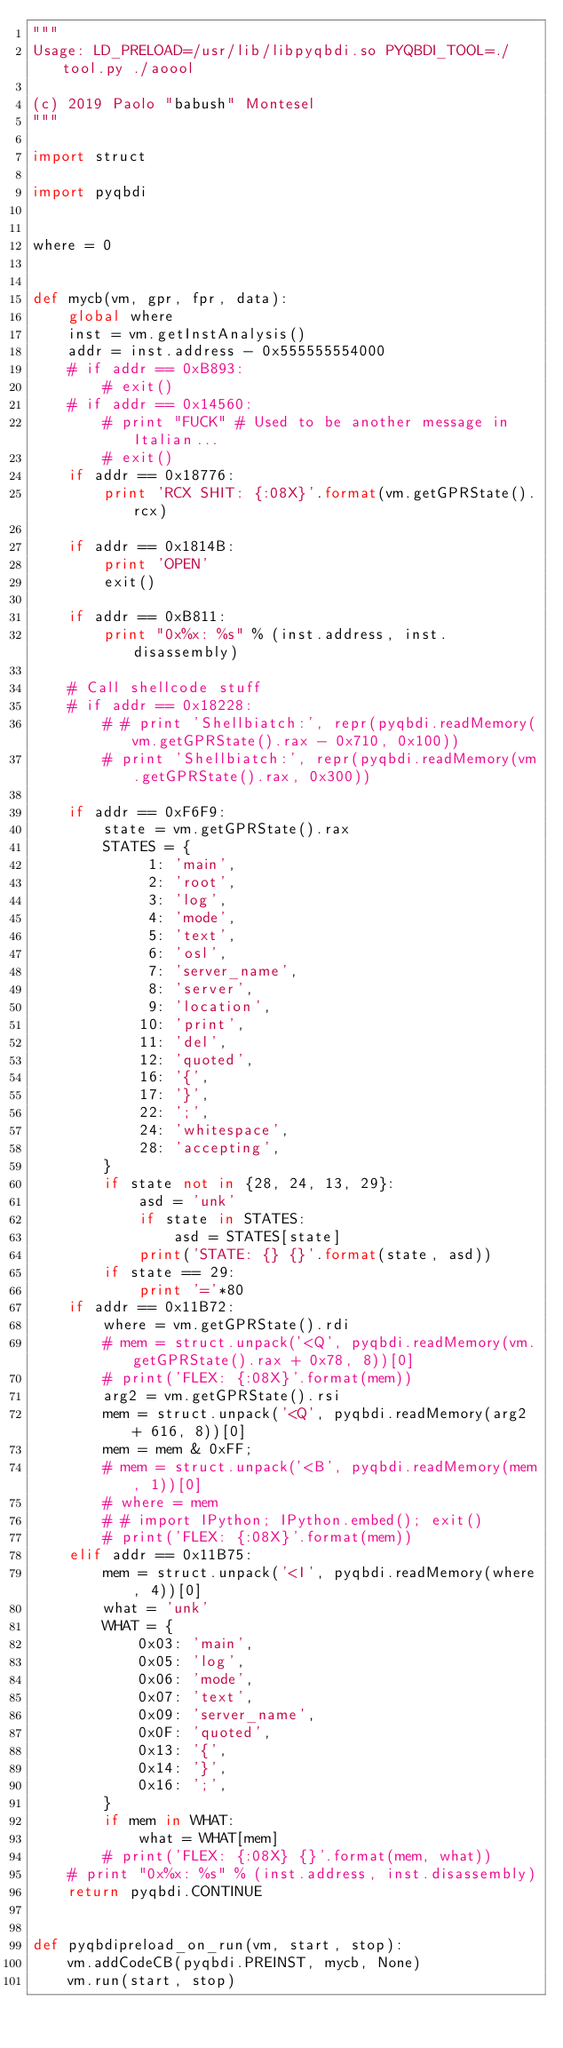Convert code to text. <code><loc_0><loc_0><loc_500><loc_500><_Python_>"""
Usage: LD_PRELOAD=/usr/lib/libpyqbdi.so PYQBDI_TOOL=./tool.py ./aoool

(c) 2019 Paolo "babush" Montesel
"""

import struct

import pyqbdi


where = 0


def mycb(vm, gpr, fpr, data):
    global where
    inst = vm.getInstAnalysis()
    addr = inst.address - 0x555555554000
    # if addr == 0xB893:
        # exit()
    # if addr == 0x14560:
        # print "FUCK" # Used to be another message in Italian...
        # exit()
    if addr == 0x18776:
        print 'RCX SHIT: {:08X}'.format(vm.getGPRState().rcx)

    if addr == 0x1814B:
        print 'OPEN'
        exit()

    if addr == 0xB811:
        print "0x%x: %s" % (inst.address, inst.disassembly)

    # Call shellcode stuff
    # if addr == 0x18228:
        # # print 'Shellbiatch:', repr(pyqbdi.readMemory(vm.getGPRState().rax - 0x710, 0x100))
        # print 'Shellbiatch:', repr(pyqbdi.readMemory(vm.getGPRState().rax, 0x300))

    if addr == 0xF6F9:
        state = vm.getGPRState().rax
        STATES = {
             1: 'main',
             2: 'root',
             3: 'log',
             4: 'mode',
             5: 'text',
             6: 'osl',
             7: 'server_name',
             8: 'server',
             9: 'location',
            10: 'print',
            11: 'del',
            12: 'quoted',
            16: '{',
            17: '}',
            22: ';',
            24: 'whitespace',
            28: 'accepting',
        }
        if state not in {28, 24, 13, 29}:
            asd = 'unk'
            if state in STATES:
                asd = STATES[state]
            print('STATE: {} {}'.format(state, asd))
        if state == 29:
            print '='*80
    if addr == 0x11B72:
        where = vm.getGPRState().rdi
        # mem = struct.unpack('<Q', pyqbdi.readMemory(vm.getGPRState().rax + 0x78, 8))[0]
        # print('FLEX: {:08X}'.format(mem))
        arg2 = vm.getGPRState().rsi
        mem = struct.unpack('<Q', pyqbdi.readMemory(arg2 + 616, 8))[0]
        mem = mem & 0xFF;
        # mem = struct.unpack('<B', pyqbdi.readMemory(mem, 1))[0]
        # where = mem
        # # import IPython; IPython.embed(); exit()
        # print('FLEX: {:08X}'.format(mem))
    elif addr == 0x11B75:
        mem = struct.unpack('<I', pyqbdi.readMemory(where, 4))[0]
        what = 'unk'
        WHAT = {
            0x03: 'main',
            0x05: 'log',
            0x06: 'mode',
            0x07: 'text',
            0x09: 'server_name',
            0x0F: 'quoted',
            0x13: '{',
            0x14: '}',
            0x16: ';',
        }
        if mem in WHAT:
            what = WHAT[mem]
        # print('FLEX: {:08X} {}'.format(mem, what))
    # print "0x%x: %s" % (inst.address, inst.disassembly)
    return pyqbdi.CONTINUE


def pyqbdipreload_on_run(vm, start, stop):
    vm.addCodeCB(pyqbdi.PREINST, mycb, None)
    vm.run(start, stop)

</code> 